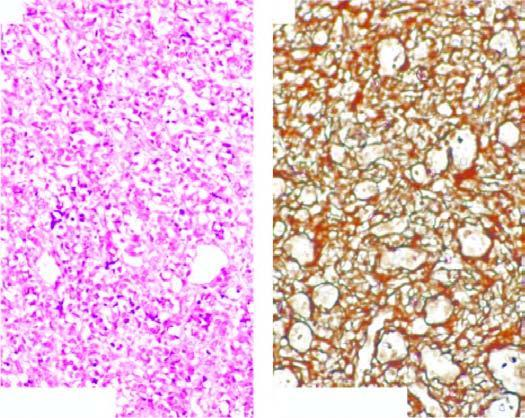what are lined by multiple layers of plump endothelial cells having minimal mitotic activity obliterating the lumina?
Answer the question using a single word or phrase. Vascular channels 